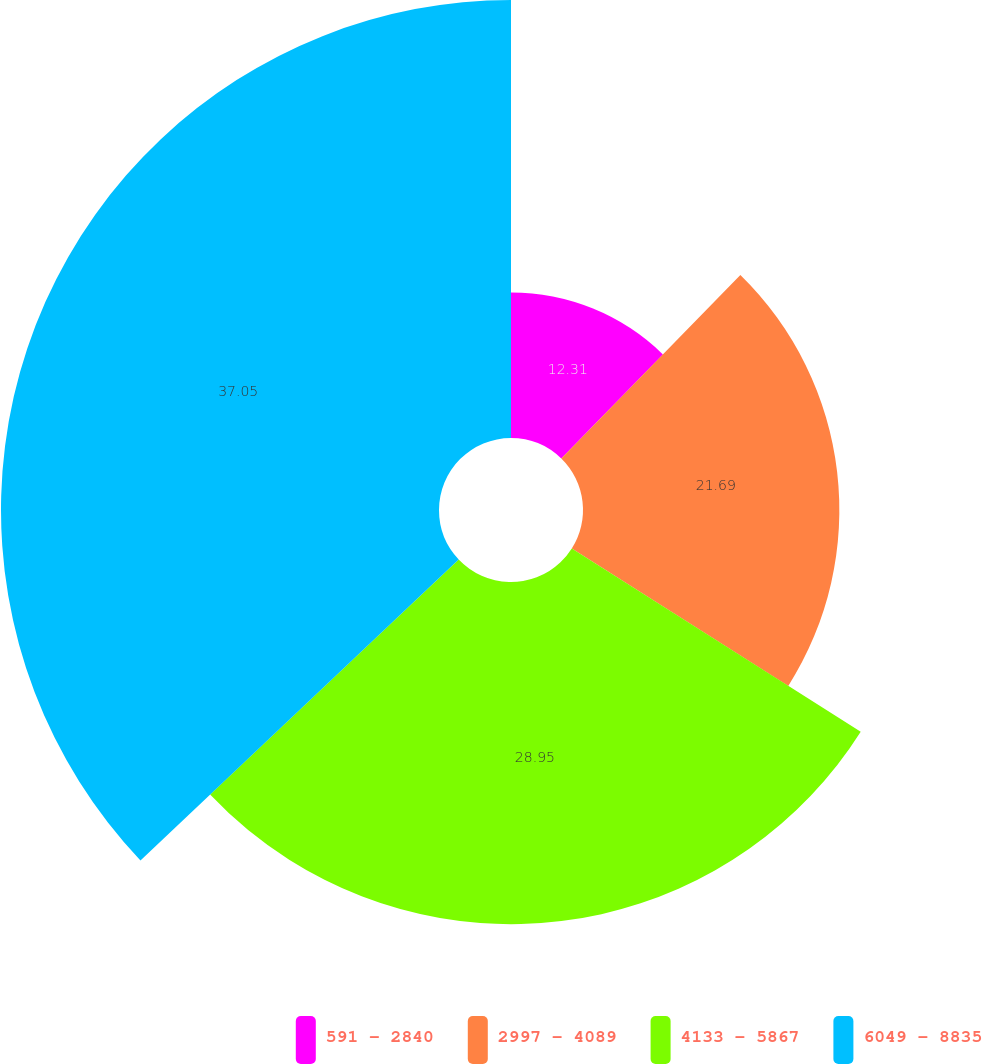Convert chart. <chart><loc_0><loc_0><loc_500><loc_500><pie_chart><fcel>591 - 2840<fcel>2997 - 4089<fcel>4133 - 5867<fcel>6049 - 8835<nl><fcel>12.31%<fcel>21.69%<fcel>28.95%<fcel>37.06%<nl></chart> 